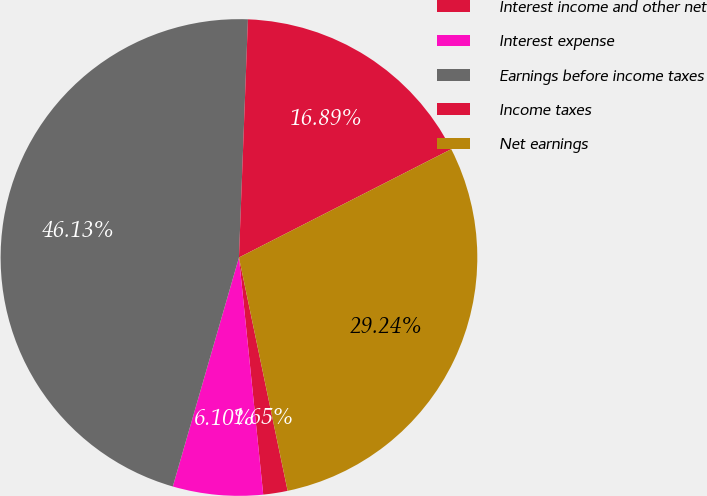Convert chart to OTSL. <chart><loc_0><loc_0><loc_500><loc_500><pie_chart><fcel>Interest income and other net<fcel>Interest expense<fcel>Earnings before income taxes<fcel>Income taxes<fcel>Net earnings<nl><fcel>1.65%<fcel>6.1%<fcel>46.13%<fcel>16.89%<fcel>29.24%<nl></chart> 